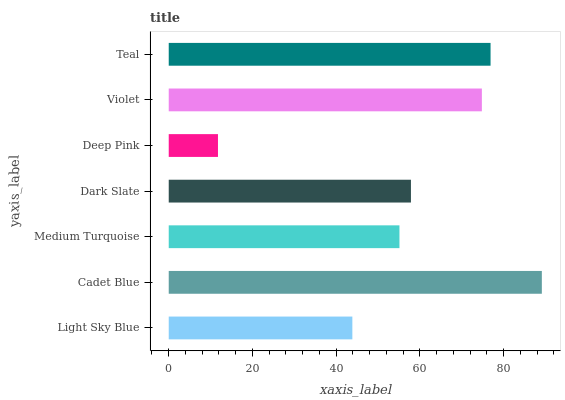Is Deep Pink the minimum?
Answer yes or no. Yes. Is Cadet Blue the maximum?
Answer yes or no. Yes. Is Medium Turquoise the minimum?
Answer yes or no. No. Is Medium Turquoise the maximum?
Answer yes or no. No. Is Cadet Blue greater than Medium Turquoise?
Answer yes or no. Yes. Is Medium Turquoise less than Cadet Blue?
Answer yes or no. Yes. Is Medium Turquoise greater than Cadet Blue?
Answer yes or no. No. Is Cadet Blue less than Medium Turquoise?
Answer yes or no. No. Is Dark Slate the high median?
Answer yes or no. Yes. Is Dark Slate the low median?
Answer yes or no. Yes. Is Violet the high median?
Answer yes or no. No. Is Cadet Blue the low median?
Answer yes or no. No. 